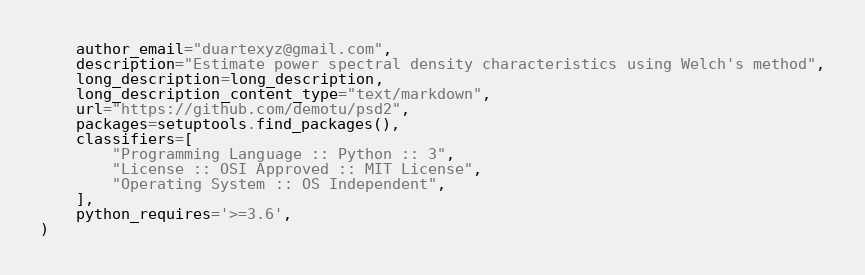<code> <loc_0><loc_0><loc_500><loc_500><_Python_>    author_email="duartexyz@gmail.com",
    description="Estimate power spectral density characteristics using Welch's method",
    long_description=long_description,
    long_description_content_type="text/markdown",
    url="https://github.com/demotu/psd2",
    packages=setuptools.find_packages(),
    classifiers=[
        "Programming Language :: Python :: 3",
        "License :: OSI Approved :: MIT License",
        "Operating System :: OS Independent",
    ],
    python_requires='>=3.6',
)
</code> 